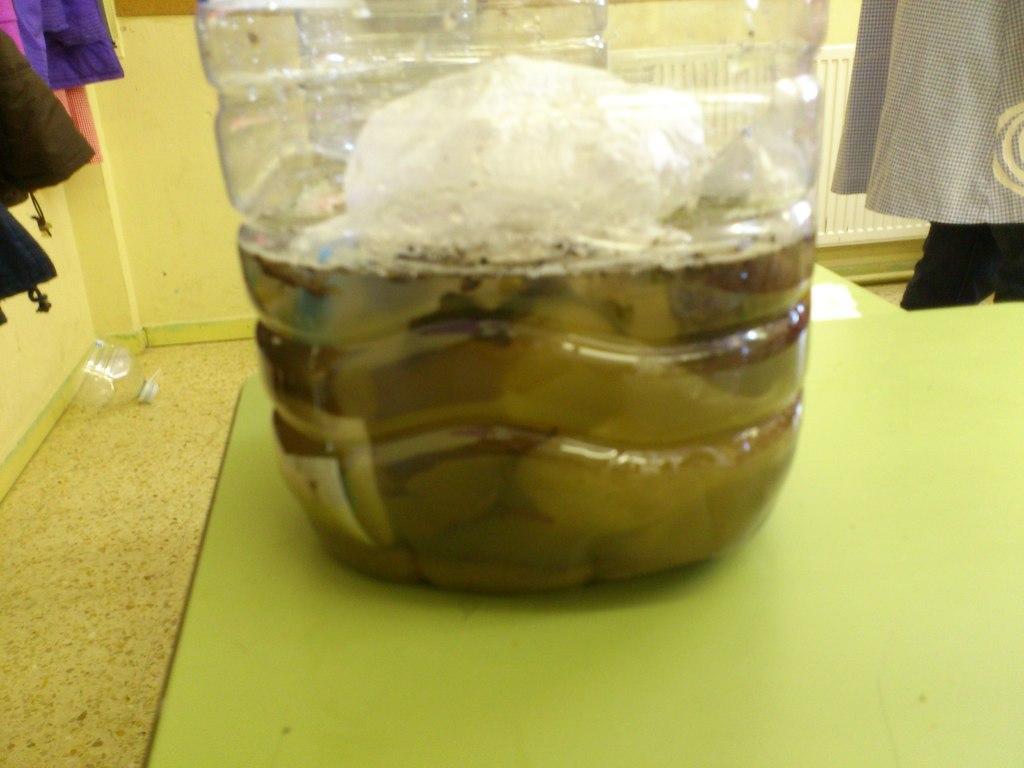Could you give a brief overview of what you see in this image? In the center of the image we can see one table. On the table, we can see one bottle and one paper. In the bottle, we can see some liquid. In the background there is a wall, one plastic object, clothes and a few other objects. 